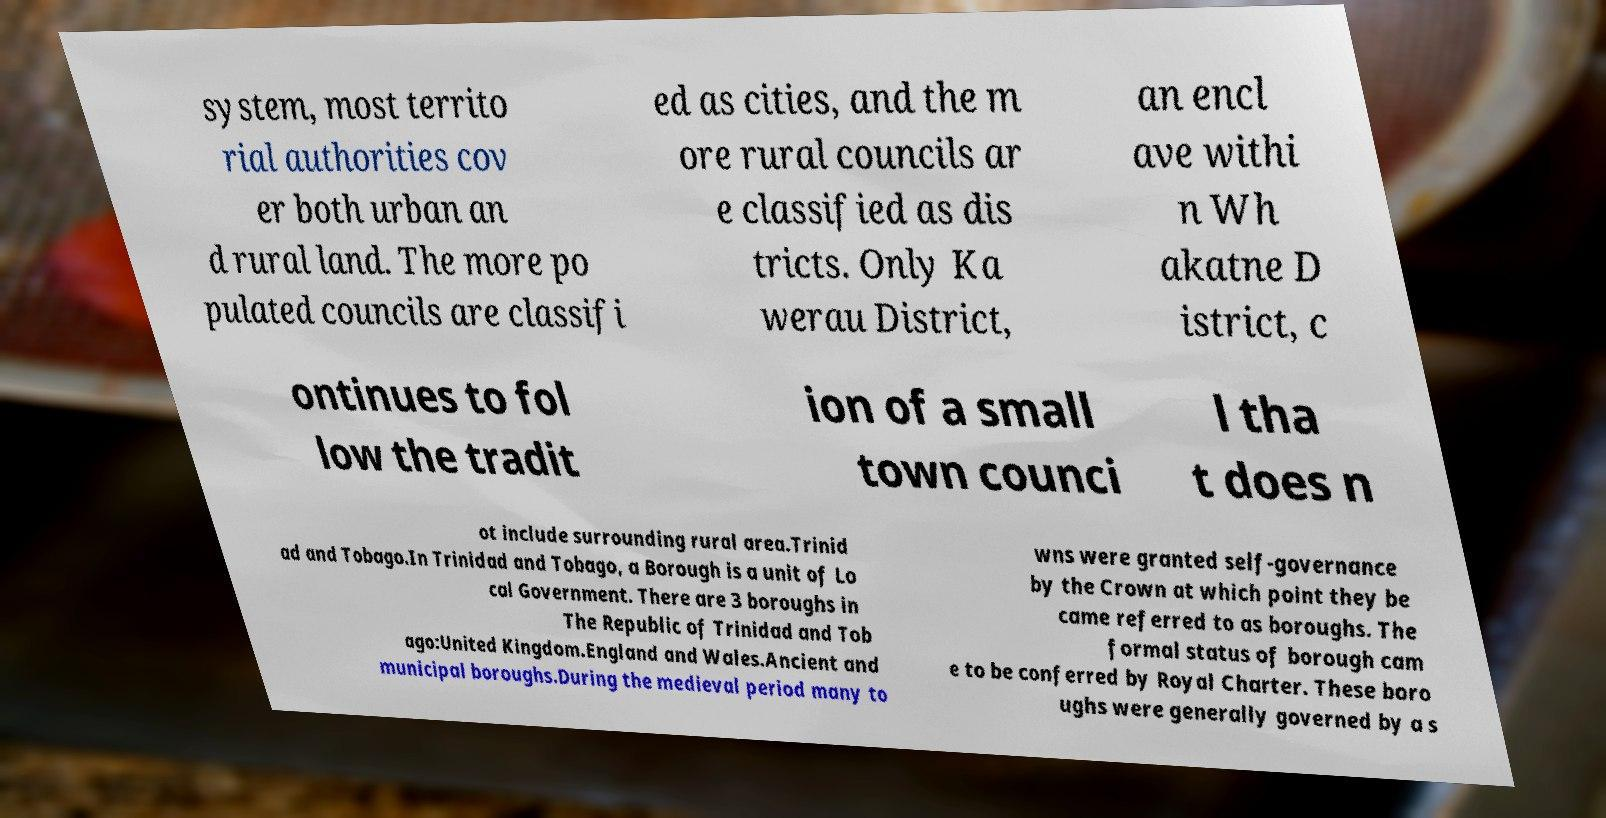Please identify and transcribe the text found in this image. system, most territo rial authorities cov er both urban an d rural land. The more po pulated councils are classifi ed as cities, and the m ore rural councils ar e classified as dis tricts. Only Ka werau District, an encl ave withi n Wh akatne D istrict, c ontinues to fol low the tradit ion of a small town counci l tha t does n ot include surrounding rural area.Trinid ad and Tobago.In Trinidad and Tobago, a Borough is a unit of Lo cal Government. There are 3 boroughs in The Republic of Trinidad and Tob ago:United Kingdom.England and Wales.Ancient and municipal boroughs.During the medieval period many to wns were granted self-governance by the Crown at which point they be came referred to as boroughs. The formal status of borough cam e to be conferred by Royal Charter. These boro ughs were generally governed by a s 